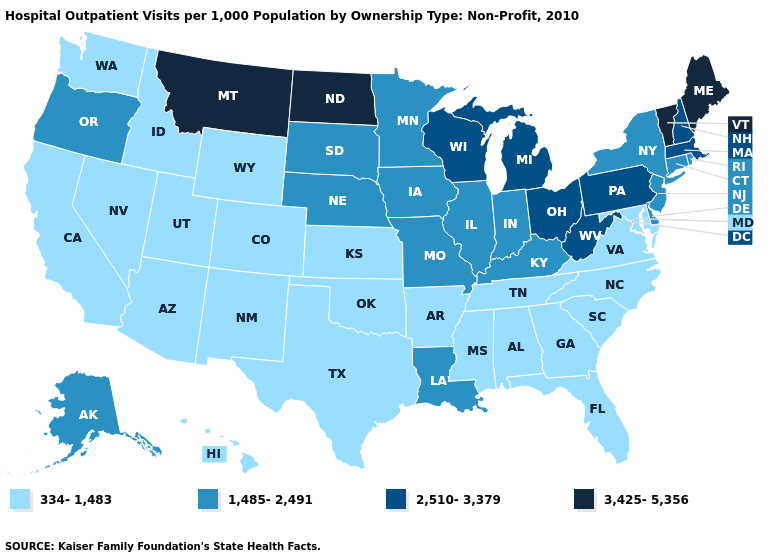Which states have the highest value in the USA?
Keep it brief. Maine, Montana, North Dakota, Vermont. Does Wisconsin have the same value as Mississippi?
Be succinct. No. What is the value of Maryland?
Concise answer only. 334-1,483. Among the states that border Texas , does Louisiana have the lowest value?
Be succinct. No. What is the lowest value in the USA?
Answer briefly. 334-1,483. Does the map have missing data?
Write a very short answer. No. Does Arkansas have the highest value in the South?
Keep it brief. No. Is the legend a continuous bar?
Short answer required. No. Name the states that have a value in the range 2,510-3,379?
Write a very short answer. Massachusetts, Michigan, New Hampshire, Ohio, Pennsylvania, West Virginia, Wisconsin. Name the states that have a value in the range 2,510-3,379?
Give a very brief answer. Massachusetts, Michigan, New Hampshire, Ohio, Pennsylvania, West Virginia, Wisconsin. What is the value of Connecticut?
Give a very brief answer. 1,485-2,491. What is the value of California?
Give a very brief answer. 334-1,483. Name the states that have a value in the range 1,485-2,491?
Concise answer only. Alaska, Connecticut, Delaware, Illinois, Indiana, Iowa, Kentucky, Louisiana, Minnesota, Missouri, Nebraska, New Jersey, New York, Oregon, Rhode Island, South Dakota. Does West Virginia have a higher value than Ohio?
Keep it brief. No. 